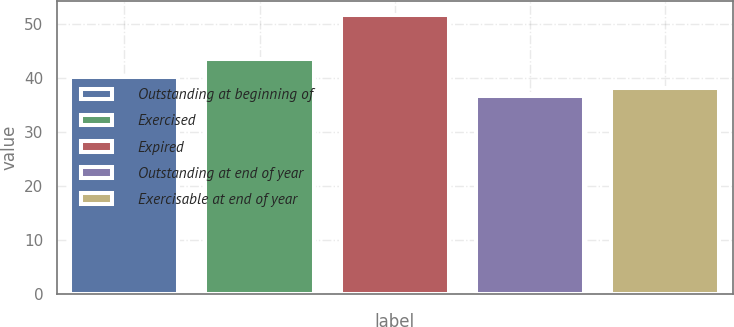<chart> <loc_0><loc_0><loc_500><loc_500><bar_chart><fcel>Outstanding at beginning of<fcel>Exercised<fcel>Expired<fcel>Outstanding at end of year<fcel>Exercisable at end of year<nl><fcel>40.19<fcel>43.53<fcel>51.62<fcel>36.66<fcel>38.16<nl></chart> 